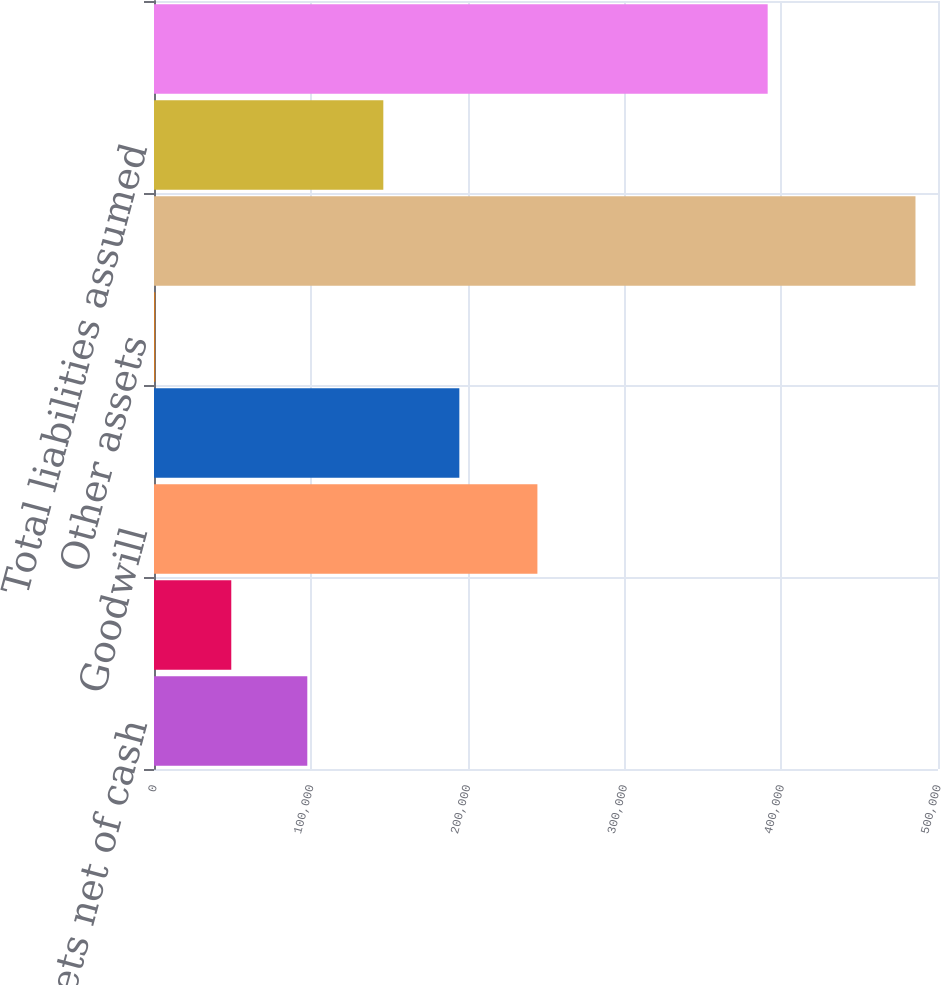Convert chart. <chart><loc_0><loc_0><loc_500><loc_500><bar_chart><fcel>Current assets net of cash<fcel>Property plant and equipment<fcel>Goodwill<fcel>Intangible assets<fcel>Other assets<fcel>Total assets acquired<fcel>Total liabilities assumed<fcel>Net assets acquired<nl><fcel>97767.4<fcel>49283.7<fcel>244519<fcel>194735<fcel>800<fcel>485637<fcel>146251<fcel>391371<nl></chart> 